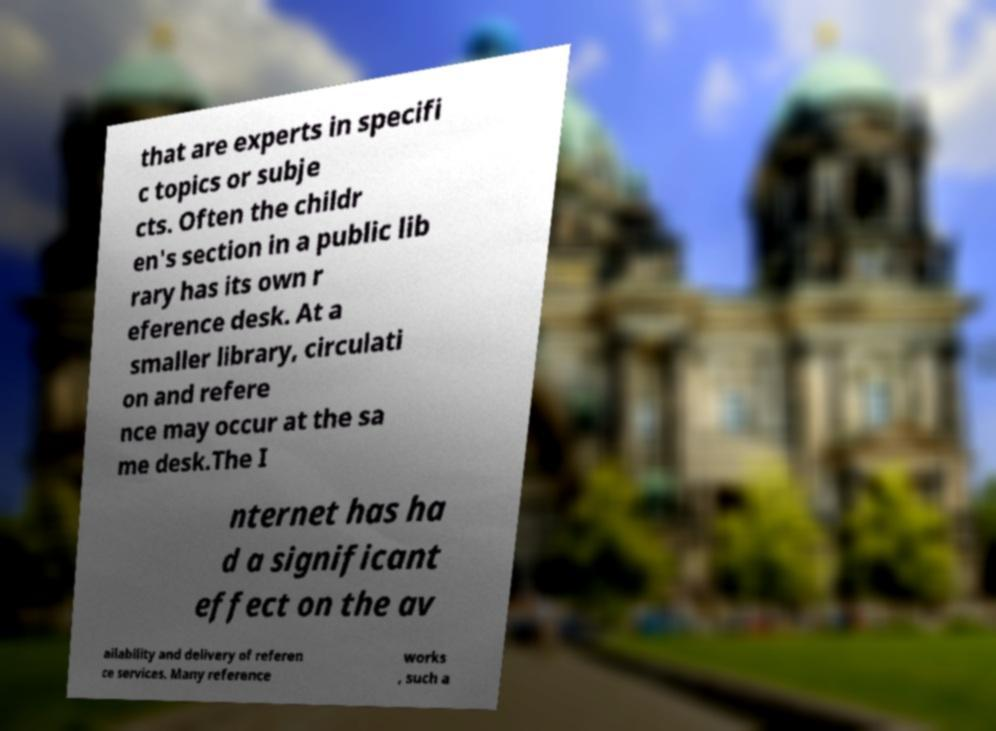Could you assist in decoding the text presented in this image and type it out clearly? that are experts in specifi c topics or subje cts. Often the childr en's section in a public lib rary has its own r eference desk. At a smaller library, circulati on and refere nce may occur at the sa me desk.The I nternet has ha d a significant effect on the av ailability and delivery of referen ce services. Many reference works , such a 